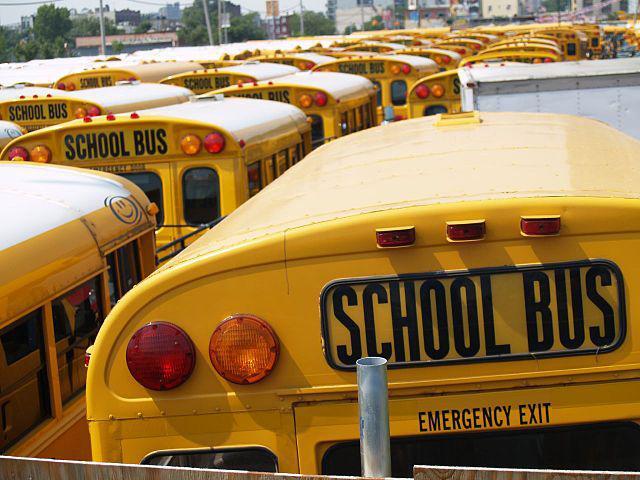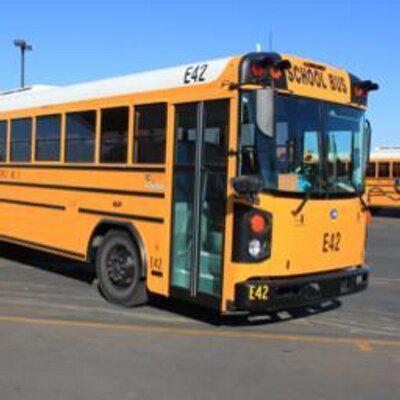The first image is the image on the left, the second image is the image on the right. Evaluate the accuracy of this statement regarding the images: "At least one image shows the rear-facing tail end of a parked yellow bus, and no image shows a non-flat bus front.". Is it true? Answer yes or no. Yes. The first image is the image on the left, the second image is the image on the right. For the images shown, is this caption "In the image to the left, there are less than six buses." true? Answer yes or no. No. 